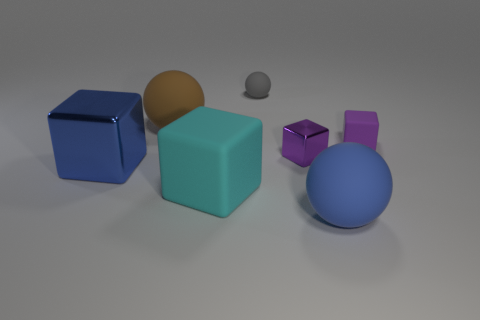Subtract all big balls. How many balls are left? 1 Subtract all blue cubes. How many cubes are left? 3 Subtract all gray cubes. Subtract all purple balls. How many cubes are left? 4 Add 2 large shiny things. How many objects exist? 9 Subtract all spheres. How many objects are left? 4 Add 6 small rubber spheres. How many small rubber spheres are left? 7 Add 5 small metallic blocks. How many small metallic blocks exist? 6 Subtract 0 purple cylinders. How many objects are left? 7 Subtract all purple shiny objects. Subtract all big blue shiny blocks. How many objects are left? 5 